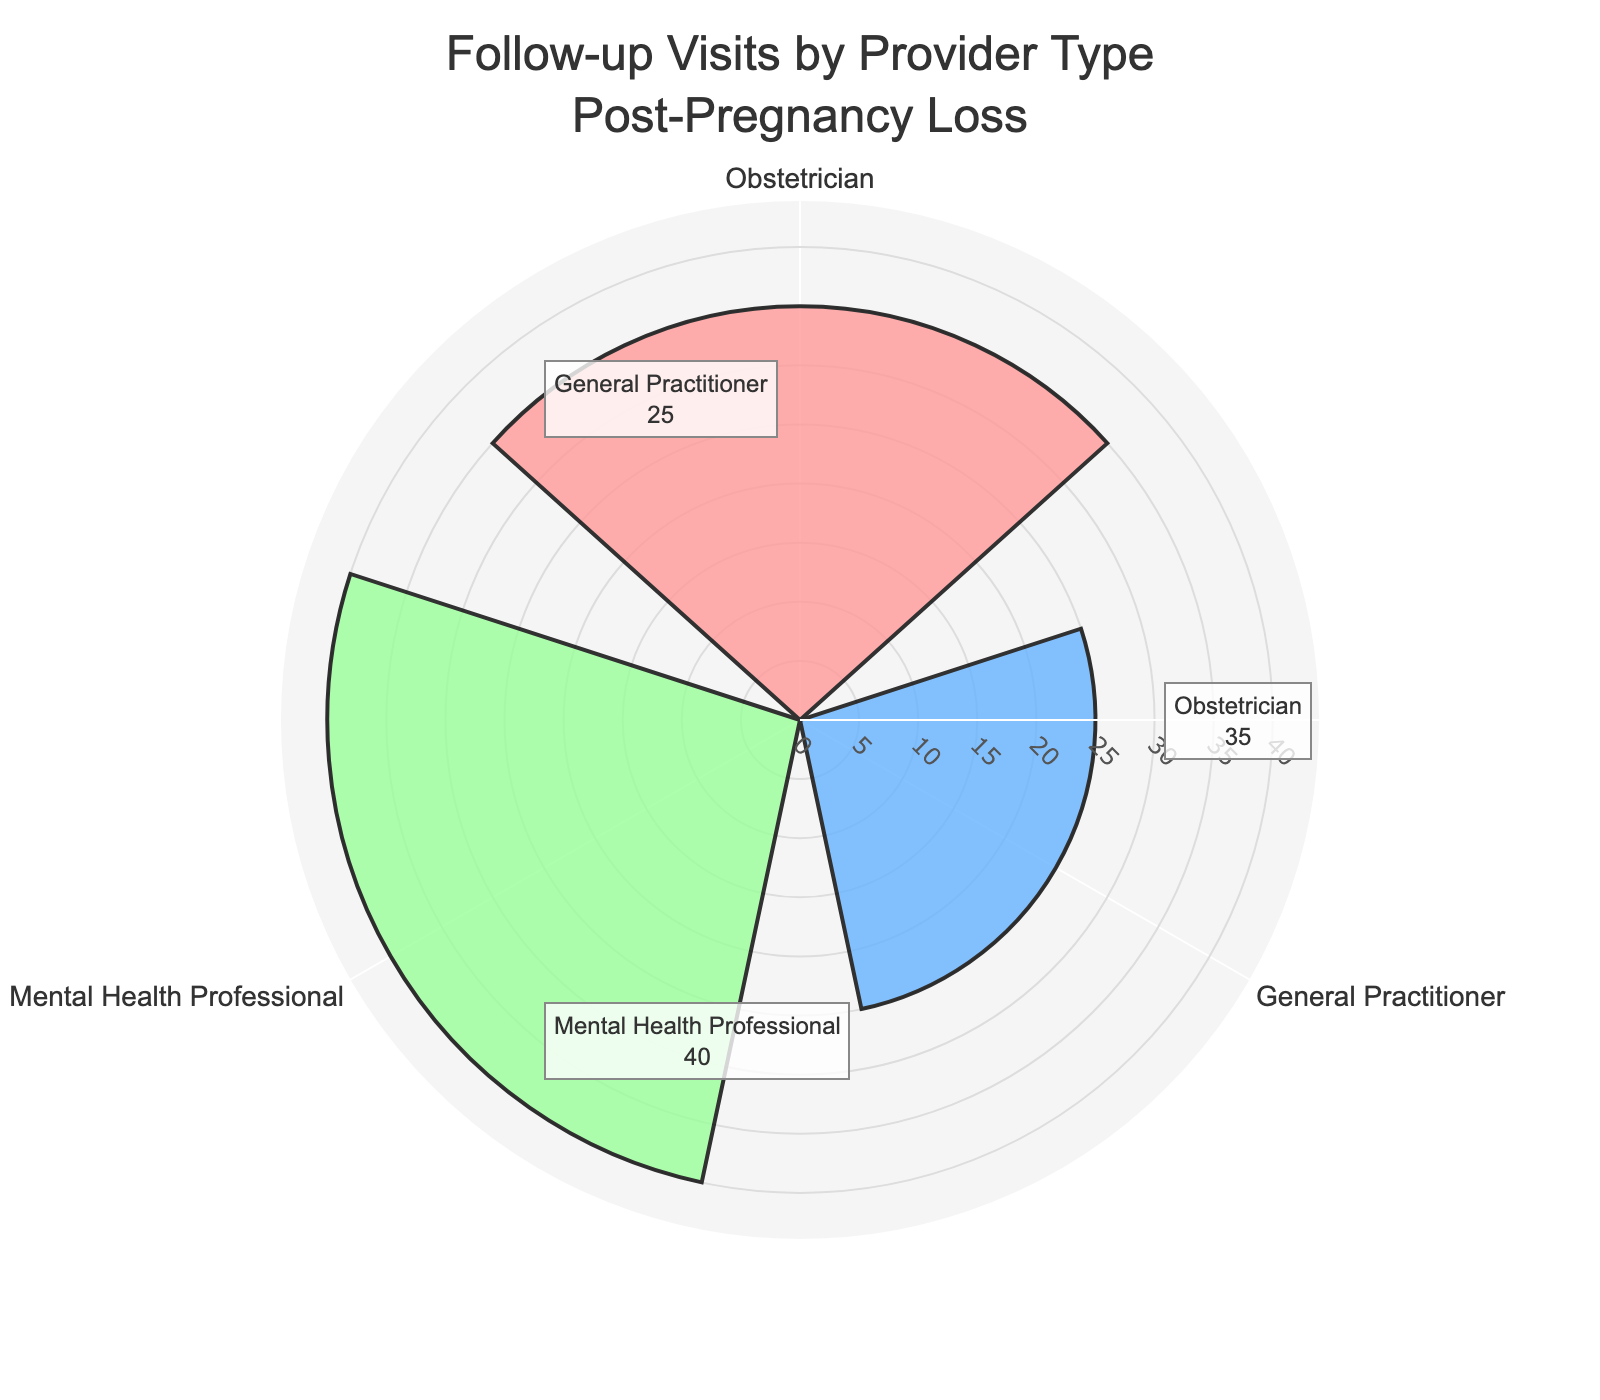What's the title of the figure? The title of the figure is located at the top and it reads "Follow-up Visits by Provider Type Post-Pregnancy Loss."
Answer: Follow-up Visits by Provider Type Post-Pregnancy Loss How many provider types are displayed in the figure? The figure shows three provider types, which are displayed as sections in the rose chart.
Answer: Three Which provider has the highest number of follow-up visits? The provider with the highest number of follow-up visits can be identified by looking at the section with the longest bar. The "Mental Health Professional" has the longest bar.
Answer: Mental Health Professional What's the total number of follow-up visits across all provider types? To find the total number of follow-up visits, add the numbers for each provider (Obstetrician: 35, General Practitioner: 25, Mental Health Professional: 40). The sum is 35 + 25 + 40.
Answer: 100 Which provider has the fewest follow-up visits? The provider with the fewest follow-up visits can be identified by looking for the shortest bar. The "General Practitioner" has the shortest bar.
Answer: General Practitioner What is the difference in the number of follow-up visits between the provider with the highest and the lowest visits? Identify the highest (Mental Health Professional: 40) and the lowest (General Practitioner: 25) numbers of visits. The difference is 40 - 25.
Answer: 15 What fraction of follow-up visits are with Obstetricians compared to the total? The number of visits with Obstetricians is 35. The total number of visits is 100. Therefore, the fraction is 35/100.
Answer: 0.35 Are the number of follow-up visits to Obstetricians and General Practitioners combined greater than or less than visits to Mental Health Professionals? Add the number of visits for Obstetricians (35) and General Practitioners (25), then compare the sum to the number of visits for Mental Health Professionals (40). 35 + 25 is 60, which is greater than 40.
Answer: Greater Do Mental Health Professionals have more follow-up visits than Obstetricians and General Practitioners combined? Combine the number of visits for Obstetricians (35) and General Practitioners (25), then compare this to the visits for Mental Health Professionals (40). 35 + 25 is 60, and 60 is greater than 40.
Answer: No What is the average number of follow-up visits per provider type? To calculate the average number of follow-up visits, add the visits for all provider types and divide by the number of provider types. (35 + 25 + 40) / 3.
Answer: 33.33 